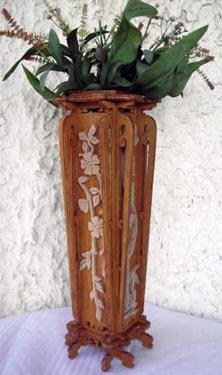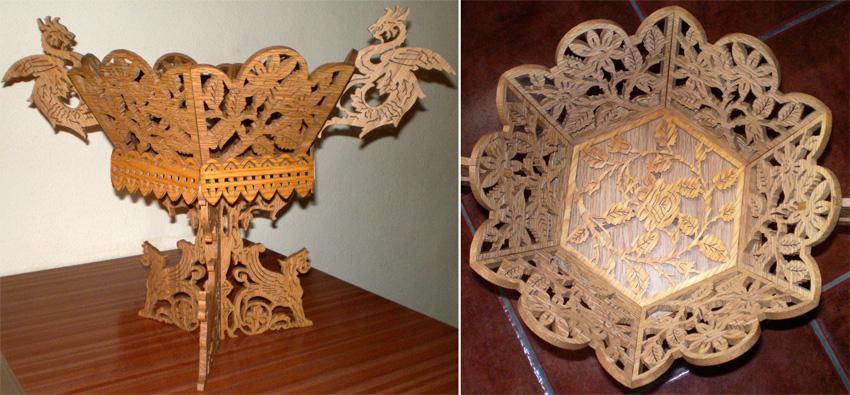The first image is the image on the left, the second image is the image on the right. Analyze the images presented: Is the assertion "Two wooden filigree stands, one larger than the other, have a cylindrical upper section with four handles, sitting on a base with four corresponding legs." valid? Answer yes or no. No. The first image is the image on the left, the second image is the image on the right. Analyze the images presented: Is the assertion "There is a set of vases with differing heights in the image on the left." valid? Answer yes or no. No. 